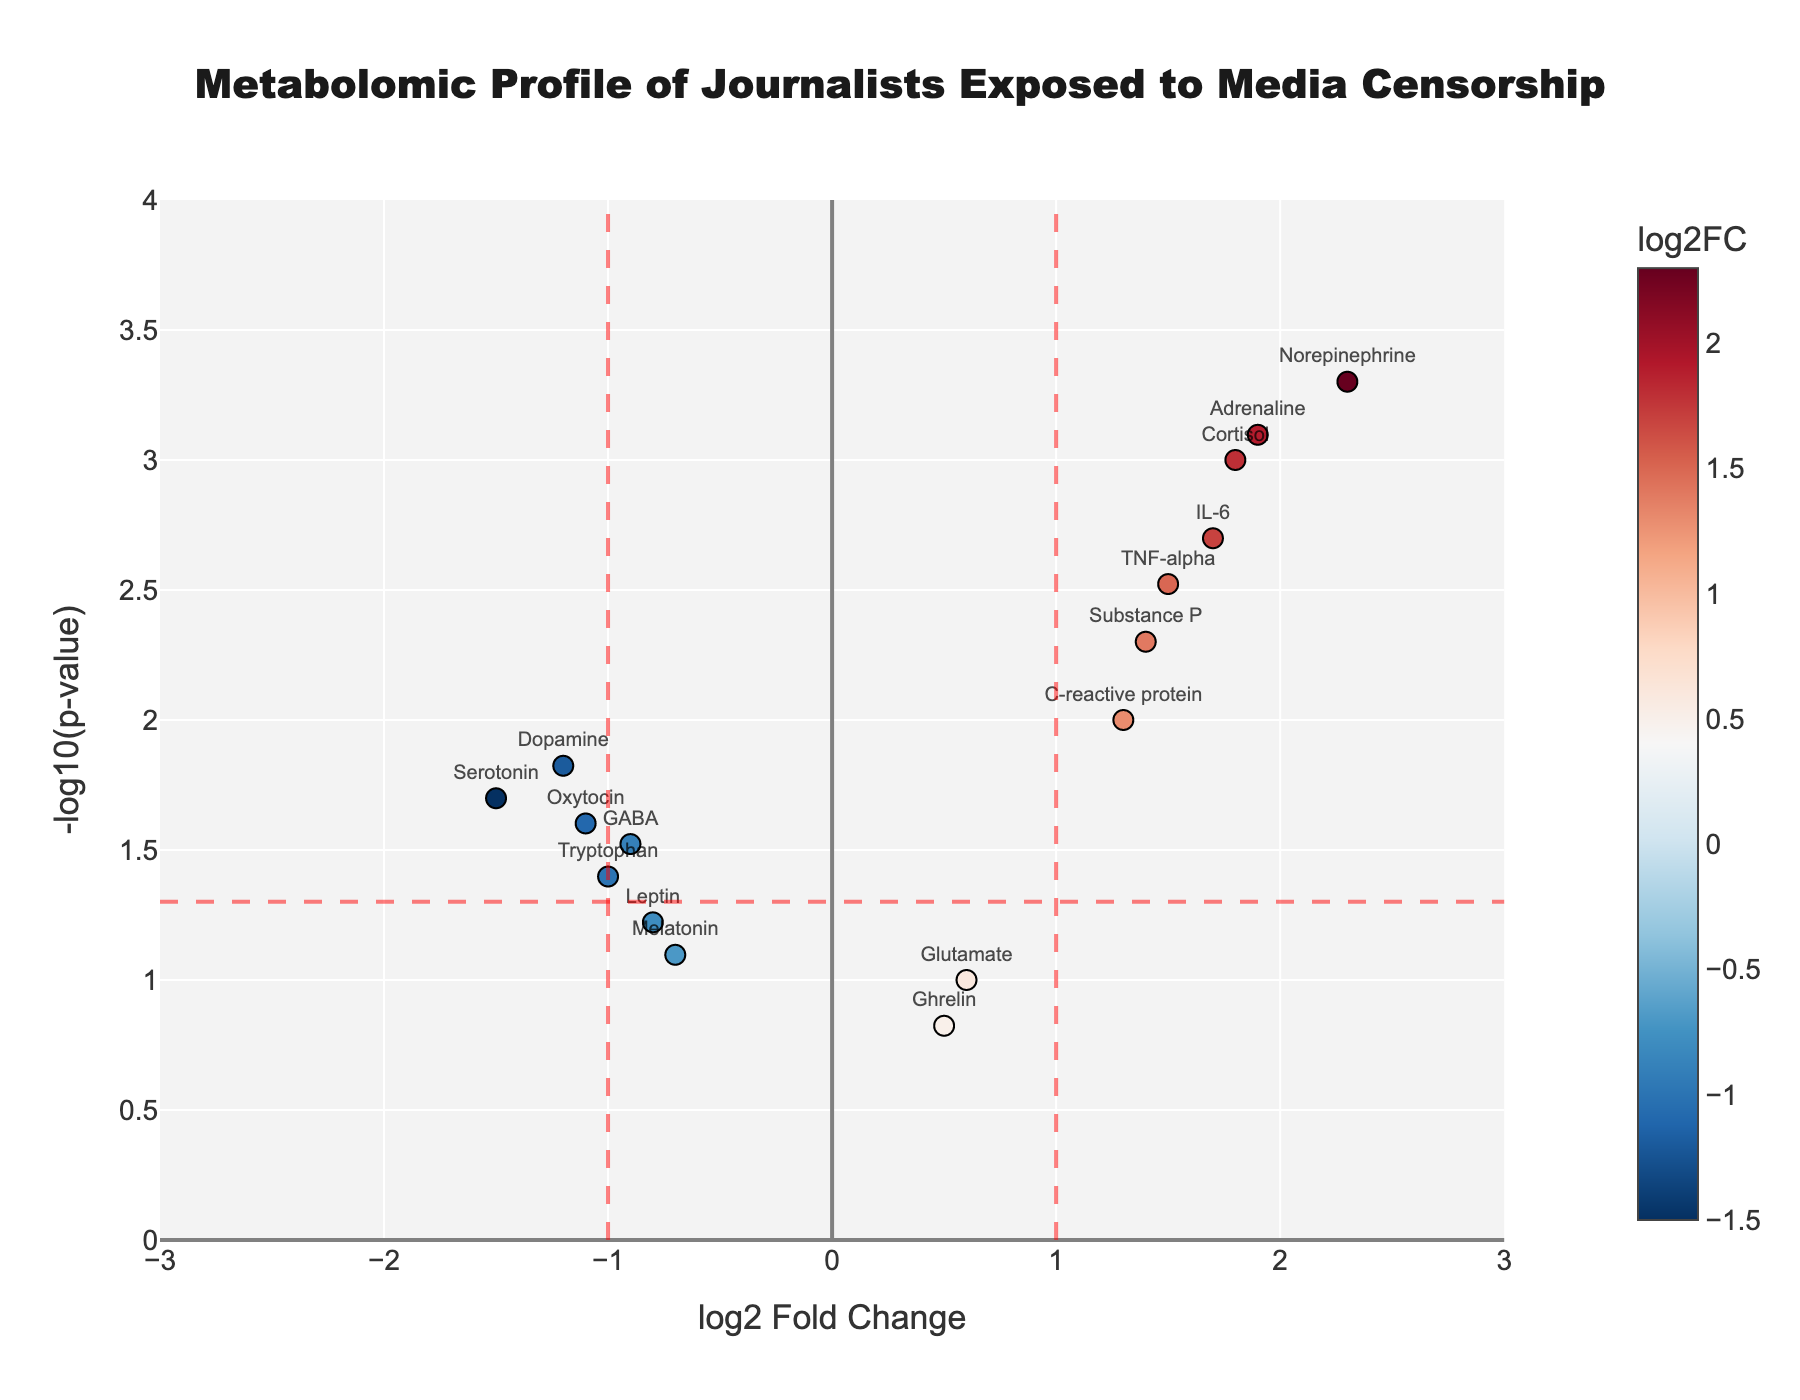Which metabolite has the highest -log10(p-value)? To determine the metabolite with the highest -log10(p-value), look at the y-axis values and find the point with the maximum value.
Answer: Norepinephrine Which metabolite shows the largest log2 Fold Change? To find the metabolite with the largest log2 Fold Change, identify the point with the maximum x-axis value.
Answer: Norepinephrine What does the horizontal red dashed line at y = -log10(0.05) signify? The horizontal red dashed line represents the significance threshold for p-values. Metabolites above this line have p-values less than 0.05, indicating statistical significance.
Answer: Significance threshold for p-value How many metabolites have log2 Fold Changes greater than 1 and are statistically significant? Count the points to the right of the vertical red dashed line at x = 1 that are also above the horizontal red dashed line.
Answer: 5 Which metabolites are found to have decreased levels in journalists exposed to high levels of media censorship? Identify the metabolites with negative log2 Fold Changes (left of the vertical red dashed line at x = -1) and check if they are above the significance threshold.
Answer: Serotonin, GABA, Dopamine, Oxytocin, Tryptophan How does the change in levels of Cortisol compare to that of Adrenaline? Compare the log2 Fold Change and -log10(p-value) for Cortisol and Adrenaline. Cortisol has a log2 Fold Change of 1.8 and Adrenaline has 1.9; both are statistically significant but Adrenaline shows a slightly higher change.
Answer: Adrenaline has a slightly higher log2 Fold Change What is the interpretation of the color scale on the plot? The color scale represents the log2 Fold Change values of the metabolites, with positive changes in one color and negative changes in another, indicating upregulation and downregulation, respectively.
Answer: Represents log2 Fold Change values Based on the plot, which inflammatory markers show significant changes? Identify the inflammatory markers such as IL-6, TNF-alpha, and C-reactive protein, and check their positions relative to the significance threshold and log2 Fold Change values.
Answer: IL-6, TNF-alpha, C-reactive protein How many metabolites are neither significantly upregulated nor downregulated? Count the points that do not meet the criteria of being above the horizontal red dashed line or outside the vertical red dashed lines.
Answer: 3 